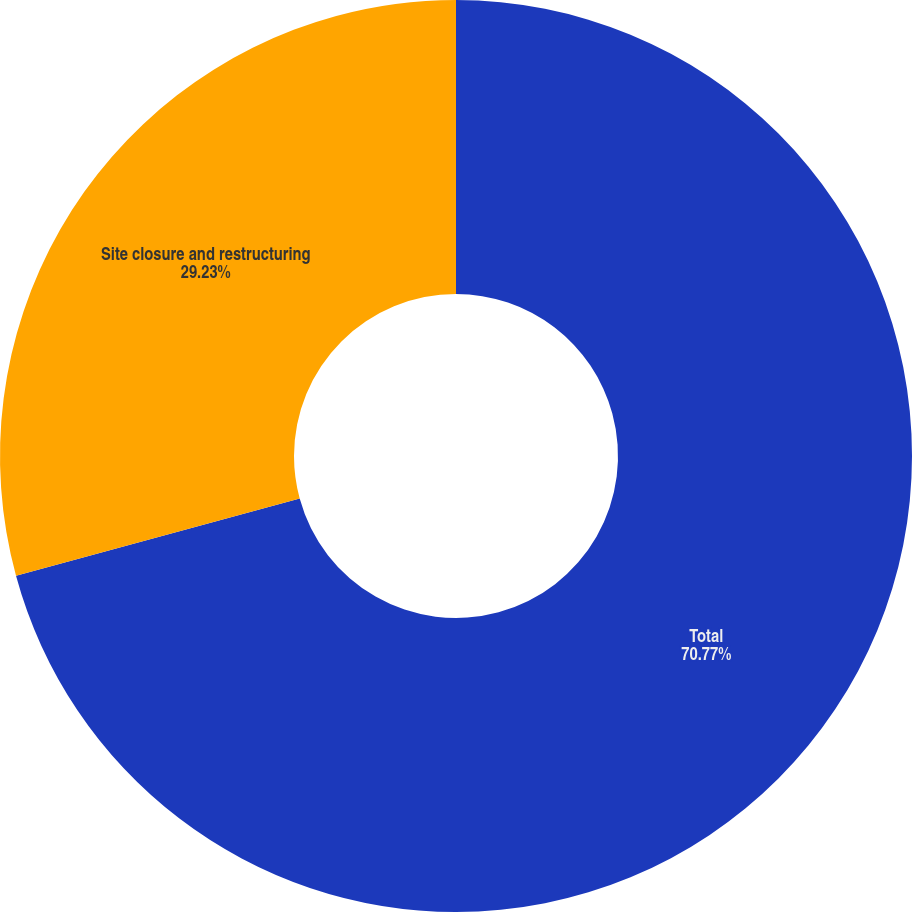Convert chart. <chart><loc_0><loc_0><loc_500><loc_500><pie_chart><fcel>Total<fcel>Site closure and restructuring<nl><fcel>70.77%<fcel>29.23%<nl></chart> 